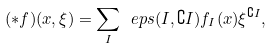<formula> <loc_0><loc_0><loc_500><loc_500>( \ast f ) ( x , \xi ) = \sum _ { I } \ e p s ( I , \complement I ) f _ { I } ( x ) \xi ^ { \complement I } ,</formula> 